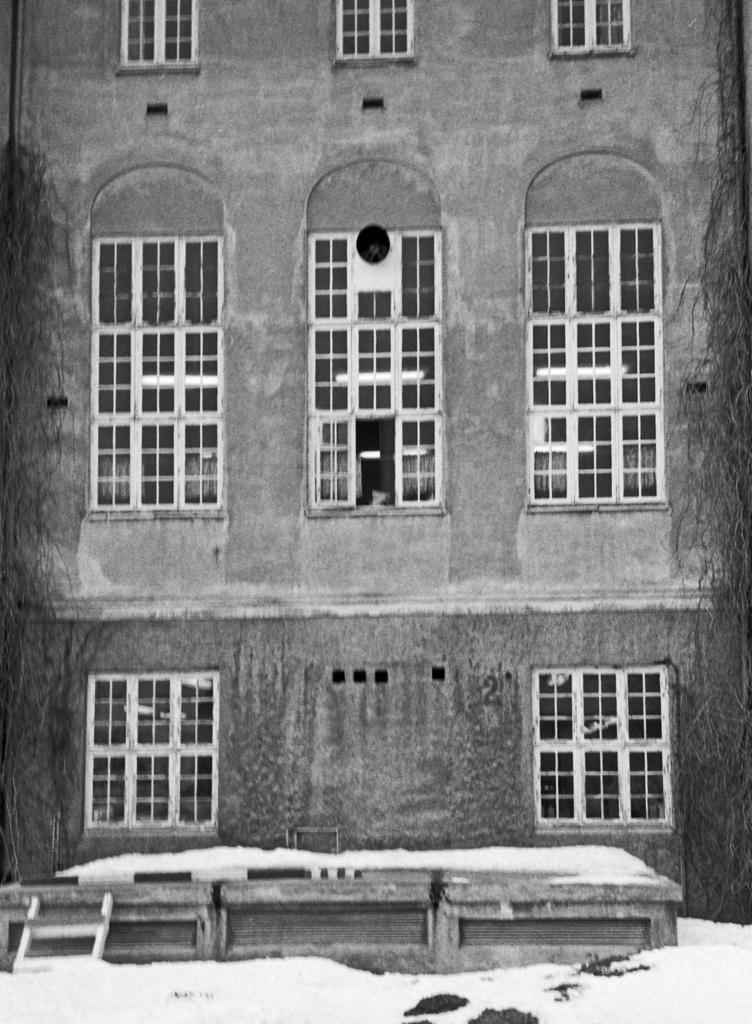How would you summarize this image in a sentence or two? In the image we can see the black and white picture of the building. 